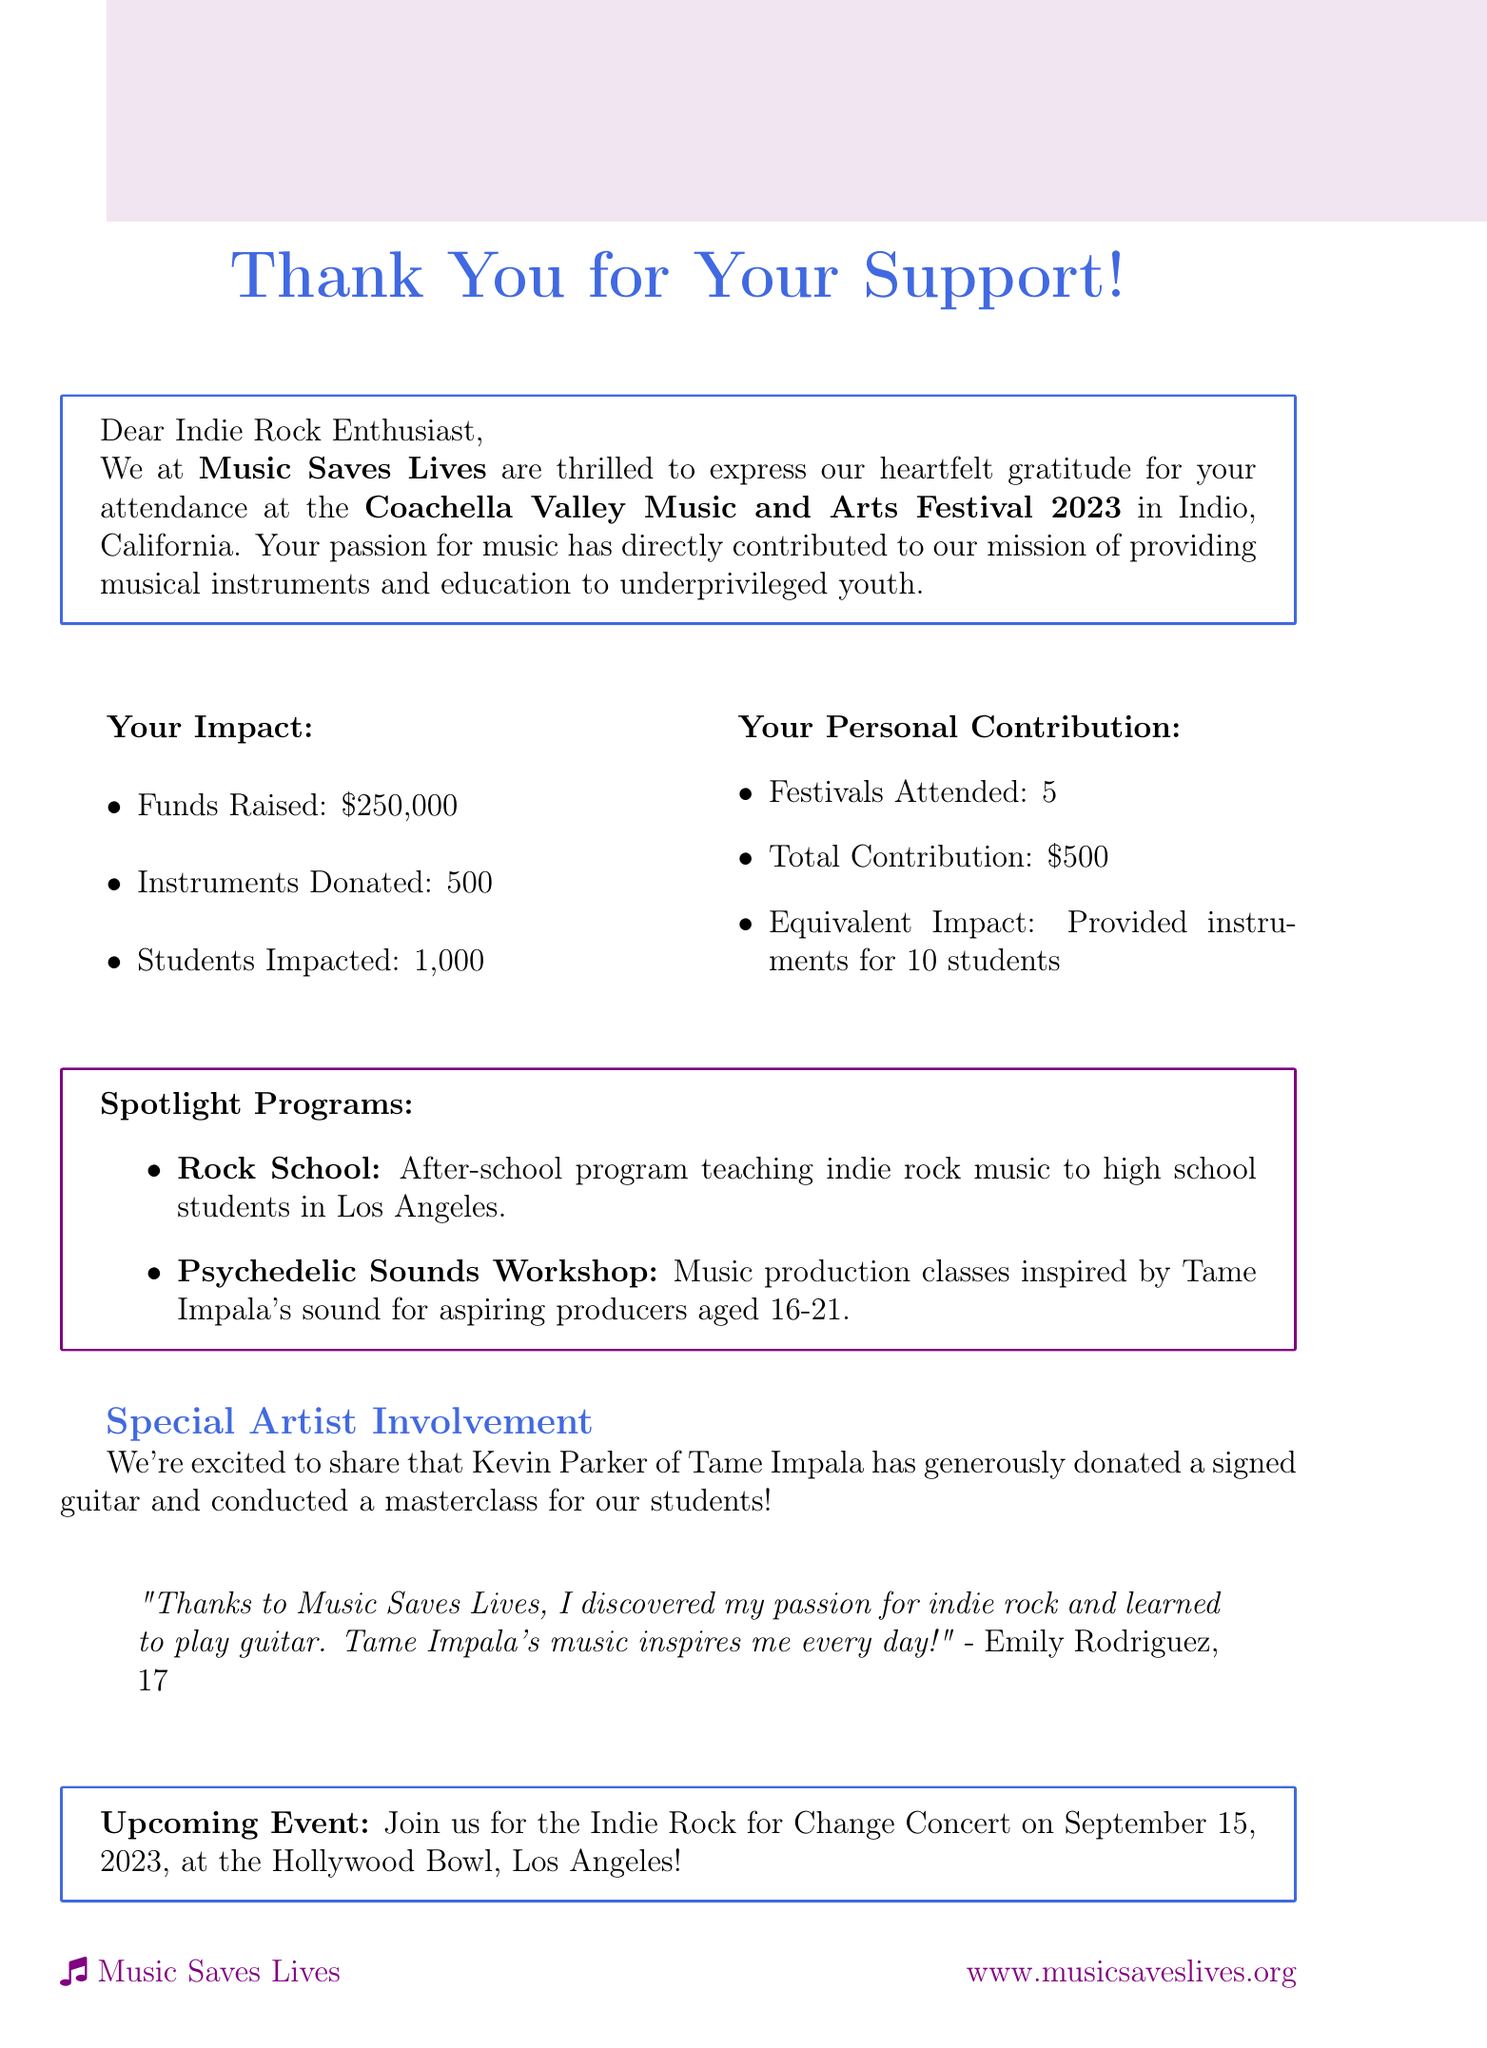What is the name of the charity organization? The document lists the charity organization as Music Saves Lives.
Answer: Music Saves Lives How much funds were raised? The document states that a total of $250,000 was raised through festival attendance.
Answer: $250,000 What year was the Coachella festival attended? The document indicates that the festival was attended in 2023.
Answer: 2023 How many students were impacted by the charity? According to the document, the number of students impacted is cited as 1,000.
Answer: 1,000 What program is specifically designed for aspiring producers aged 16-21? The document describes the Psychedelic Sounds Workshop as a program for aspiring producers aged 16-21.
Answer: Psychedelic Sounds Workshop What is the total contribution of the attendee? The document mentions that the total contribution of the attendee is $500.
Answer: $500 Who donated a signed guitar to the charity? The document highlights Kevin Parker of Tame Impala as the person who donated a signed guitar.
Answer: Kevin Parker What is the date of the upcoming Indie Rock for Change Concert? According to the document, the concert is scheduled for September 15, 2023.
Answer: September 15, 2023 Which program teaches indie rock music to teenagers? The document specifies that the Rock School teaches indie rock music to high school students.
Answer: Rock School 